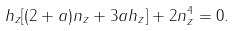Convert formula to latex. <formula><loc_0><loc_0><loc_500><loc_500>h _ { z } [ ( 2 + a ) n _ { z } + 3 a h _ { z } ] + 2 n _ { z } ^ { 4 } = 0 .</formula> 